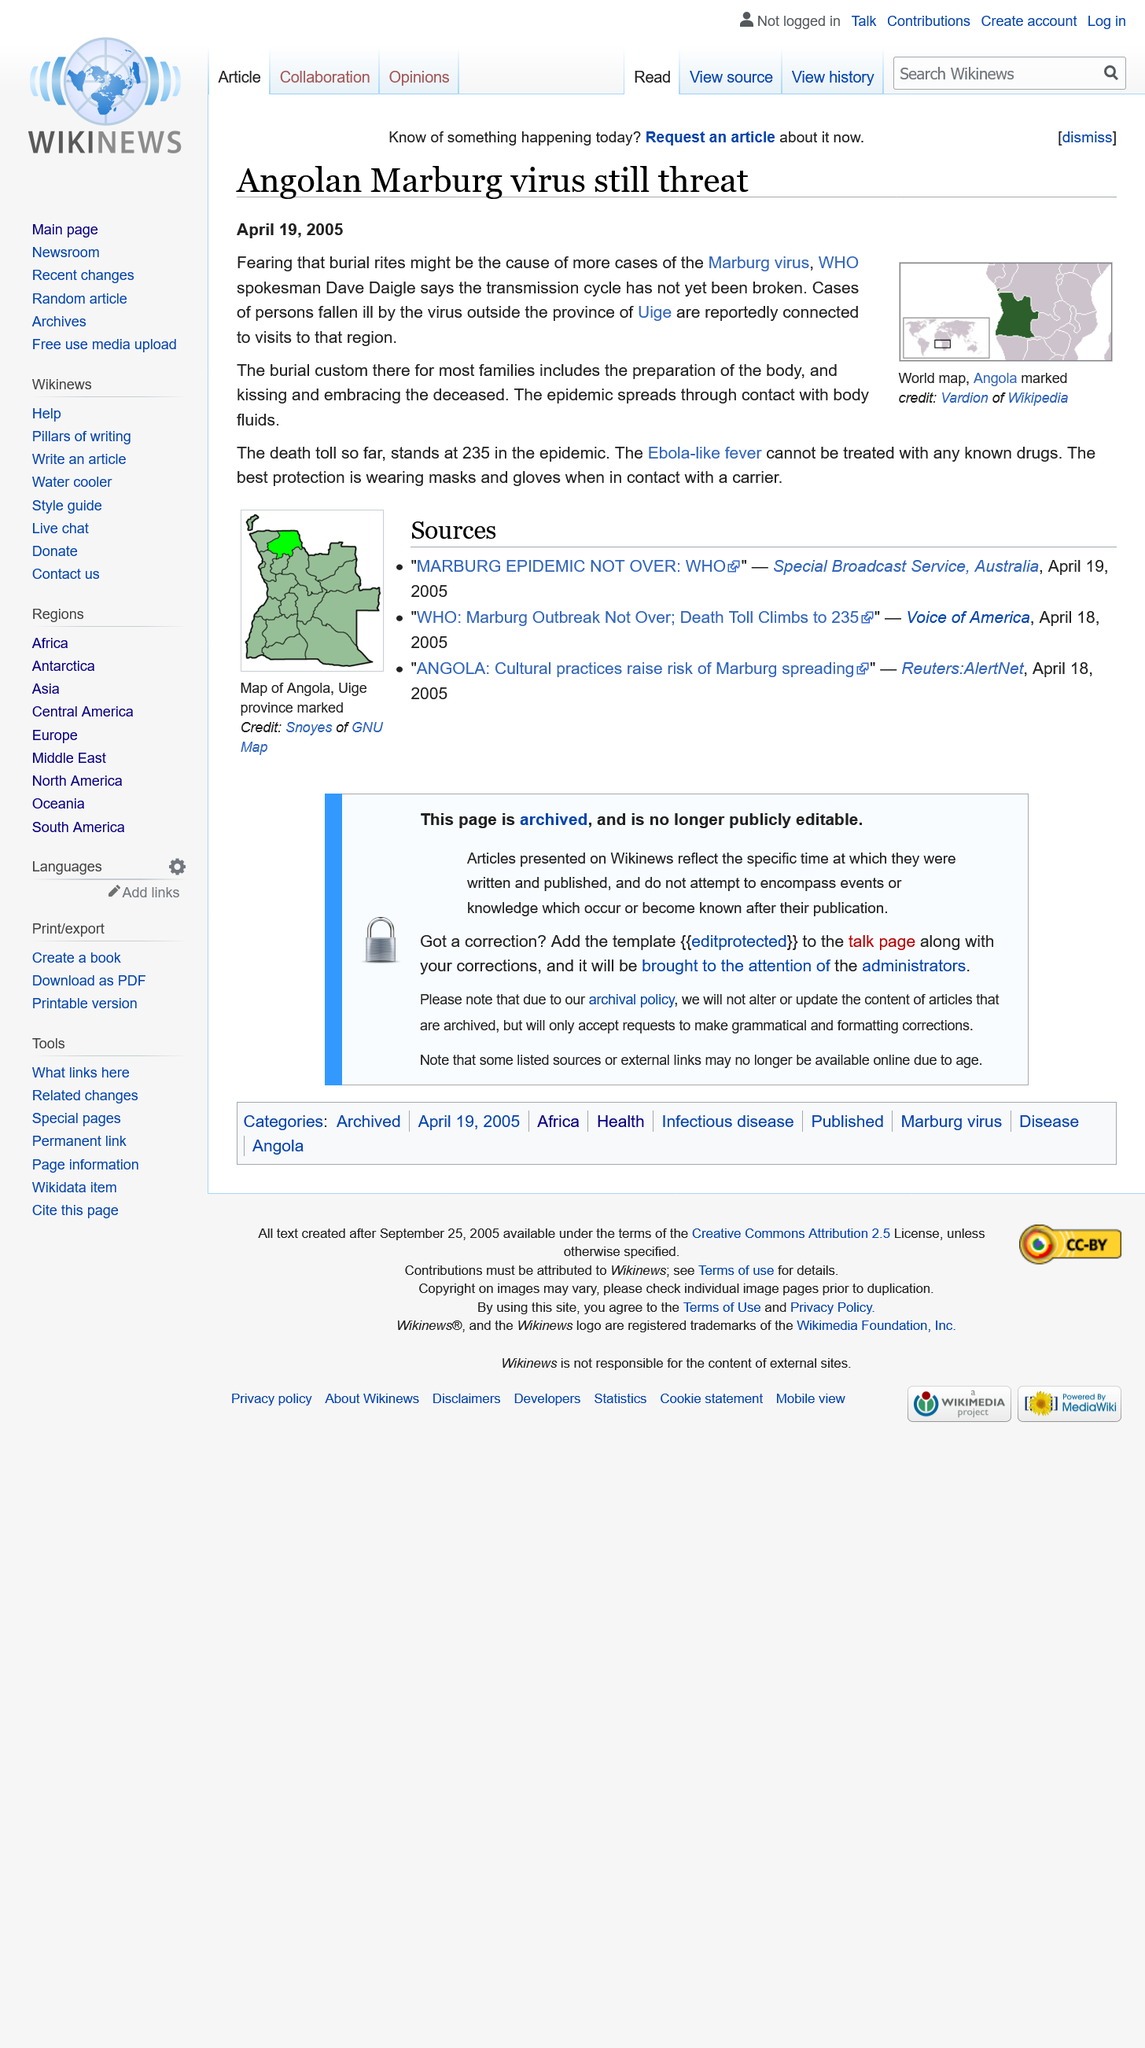Identify some key points in this picture. The most effective way to protect oneself from viruses is to wear masks and gloves when in close proximity to someone who is infected with a virus. In the Uige province of Angola, an outbreak of the Marburg virus is occurring. The death toll from the epidemic is 235. 